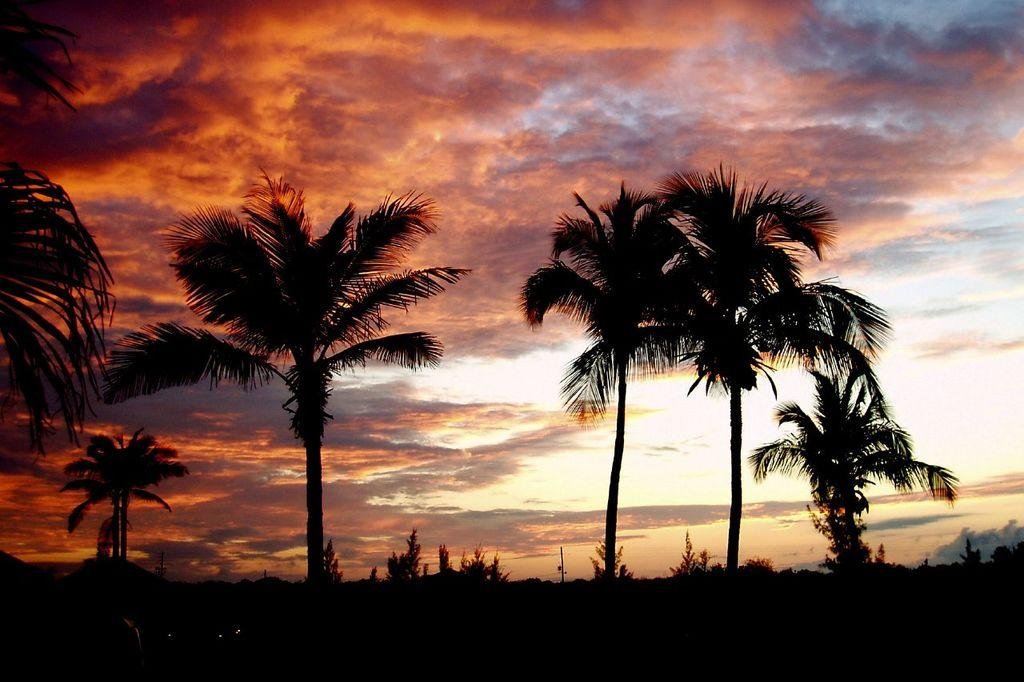What type of vegetation can be seen in the image? There are trees in the image. What part of the natural environment is visible in the image? The sky is visible in the background of the image. At what time of day was the image taken? The image was taken during nighttime. What type of shade is provided by the trees in the image? There is no indication of shade in the image, as it was taken during nighttime and the trees are not casting any shadows. 